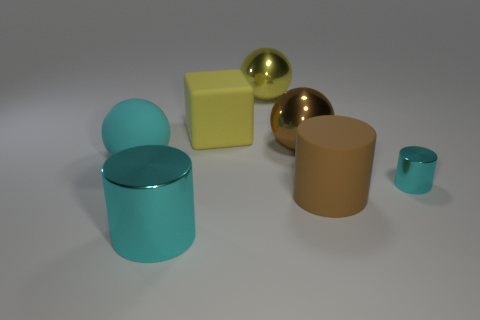Add 1 large things. How many objects exist? 8 Subtract all balls. How many objects are left? 4 Subtract all large yellow shiny objects. Subtract all big cyan spheres. How many objects are left? 5 Add 6 cyan cylinders. How many cyan cylinders are left? 8 Add 4 matte blocks. How many matte blocks exist? 5 Subtract 1 yellow spheres. How many objects are left? 6 